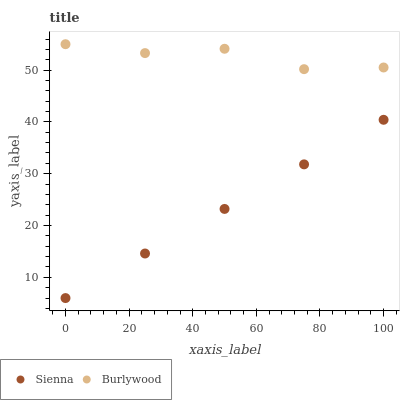Does Sienna have the minimum area under the curve?
Answer yes or no. Yes. Does Burlywood have the maximum area under the curve?
Answer yes or no. Yes. Does Burlywood have the minimum area under the curve?
Answer yes or no. No. Is Sienna the smoothest?
Answer yes or no. Yes. Is Burlywood the roughest?
Answer yes or no. Yes. Is Burlywood the smoothest?
Answer yes or no. No. Does Sienna have the lowest value?
Answer yes or no. Yes. Does Burlywood have the lowest value?
Answer yes or no. No. Does Burlywood have the highest value?
Answer yes or no. Yes. Is Sienna less than Burlywood?
Answer yes or no. Yes. Is Burlywood greater than Sienna?
Answer yes or no. Yes. Does Sienna intersect Burlywood?
Answer yes or no. No. 